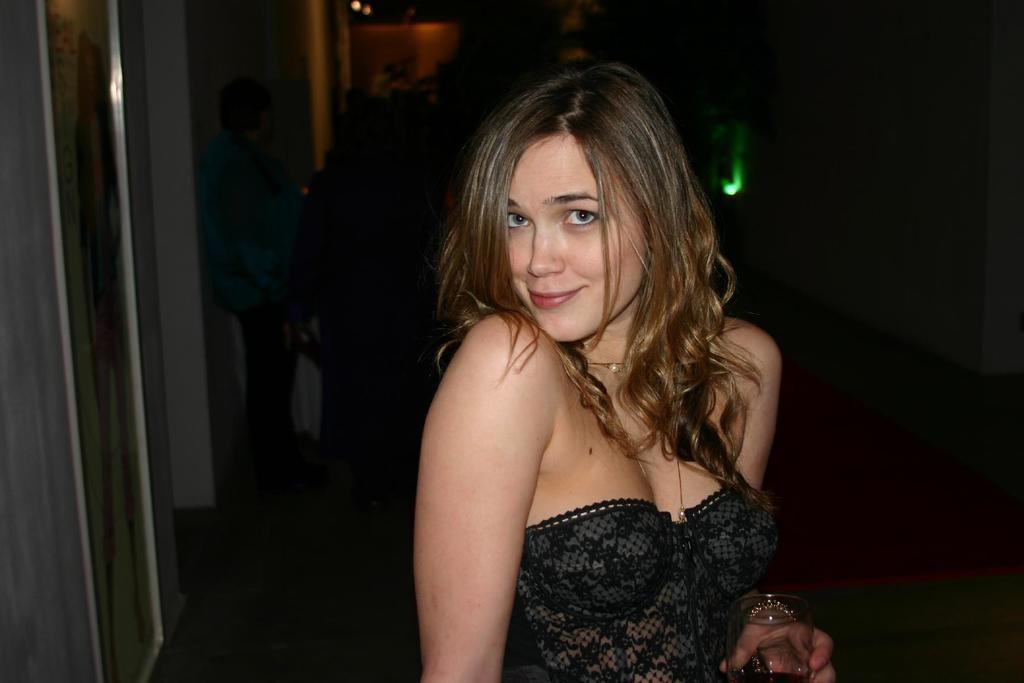How would you summarize this image in a sentence or two? In this image we can see a lady holding a glass. In the background of the image there are people. There is a wall to the left side of the image. To the right side of the image there is wall with light. At the bottom of the image there is floor with red color carpet on it. 